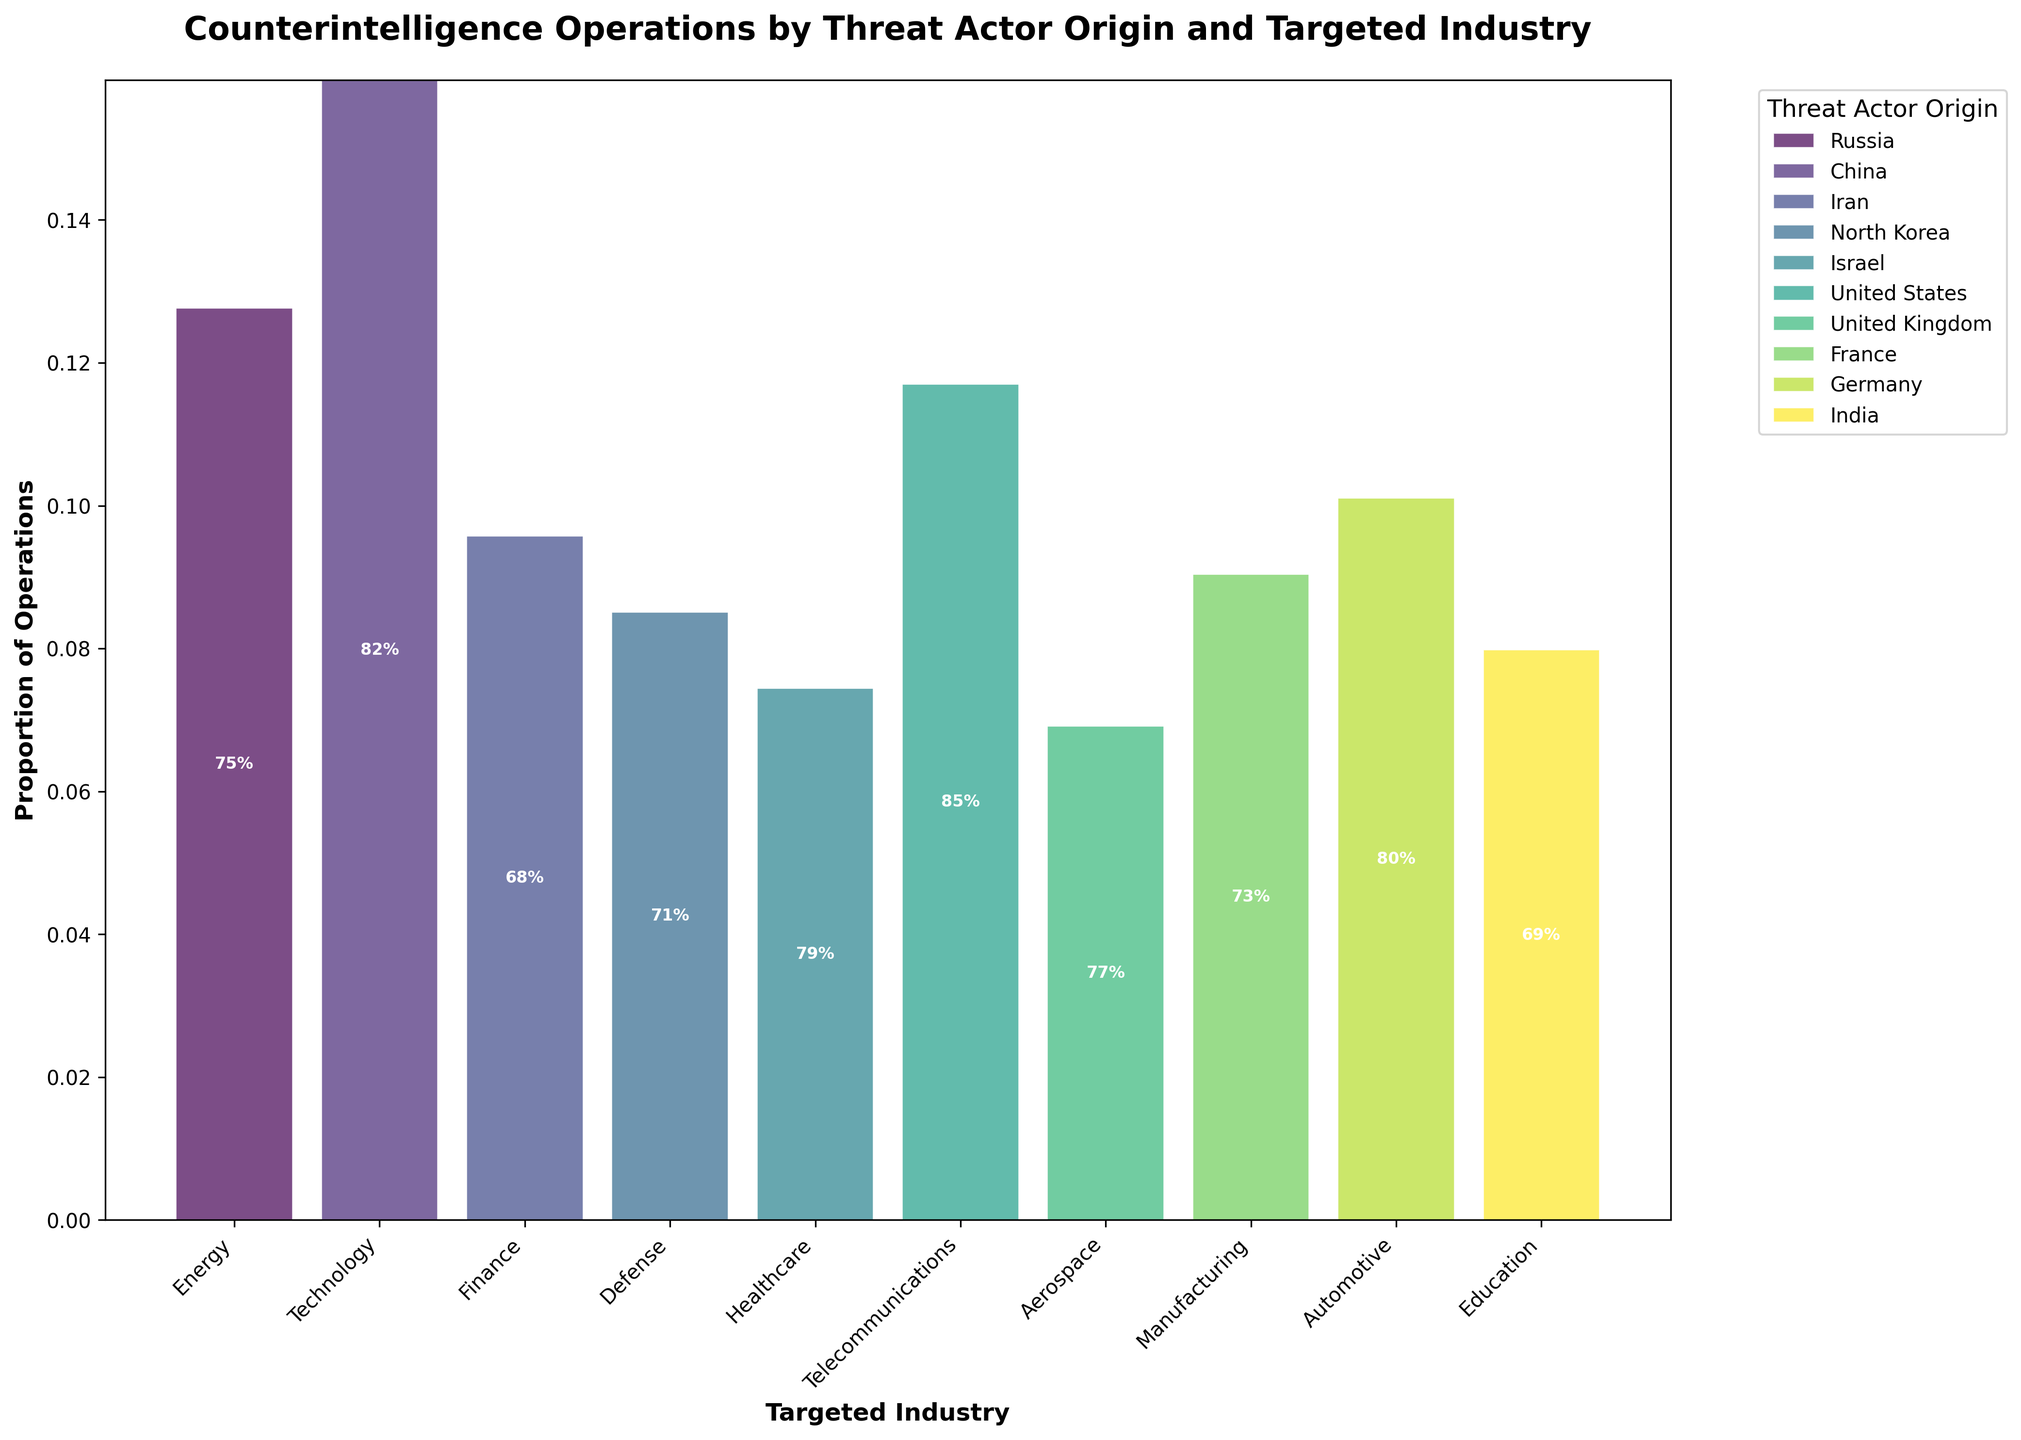What is the title of the plot? The title of the plot is prominently displayed at the top and reads "Counterintelligence Operations by Threat Actor Origin and Targeted Industry".
Answer: Counterintelligence Operations by Threat Actor Origin and Targeted Industry What are the axes labels? The x-axis is labeled "Targeted Industry", and the y-axis is labeled "Proportion of Operations".
Answer: Targeted Industry; Proportion of Operations Which targeted industry shows the highest proportion of operations? By observing the height of the bars, the Telecommunications industry shows the highest proportion of operations based on its higher total height compared to other industries.
Answer: Telecommunications Which threat actor origin has the highest success rate in the Technology industry? Looking at the annotations within the Technology industry bar, China has the highest success rate of 82%.
Answer: China What is the success rate of counterintelligence operations targeting the Healthcare industry by Israel? By locating the Healthcare industry and finding the section of the bar labeled for Israel, the success rate is annotated as 79%.
Answer: 79% Which threat actor origin targets the Automotive industry, and what is their operational success rate? The Automotive industry bar shows a section labeled for Germany with a success rate annotation of 80%.
Answer: Germany, 80% Compare the proportion of operations between Russia targeting the Energy industry and North Korea targeting the Defense industry. Which is higher? Observing the height of the sections for these origins and industries, Russia targeting the Energy industry has a higher proportion of operations compared to North Korea targeting the Defense industry.
Answer: Russia targeting Energy What combination of threat actor origin and targeted industry has the lowest operational success rate, and what is that rate? By looking at the annotations, the lowest success rate is found in operations from Iran targeting the Finance industry with a success rate of 68%.
Answer: Iran targeting Finance, 68% What is the combined proportion of operations for Telecommunications and Aerospace industries? Adding the heights of the bars for both industries, the Telecommunications industry and Aerospace industry have a combined proportion that can be estimated from the visual information but exact sum approximation may be needed.
Answer: Combined proportion Which threat actor origin has a higher success rate in the targeted Education industry: India or United States? The success rate annotation within the Education industry bar shows that India has a success rate of 69% and United States does not target the Education industry, so only India’s rate is considered.
Answer: India, 69% 